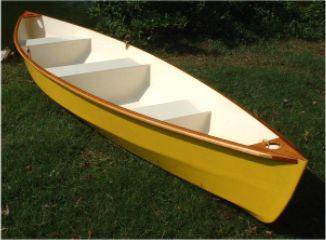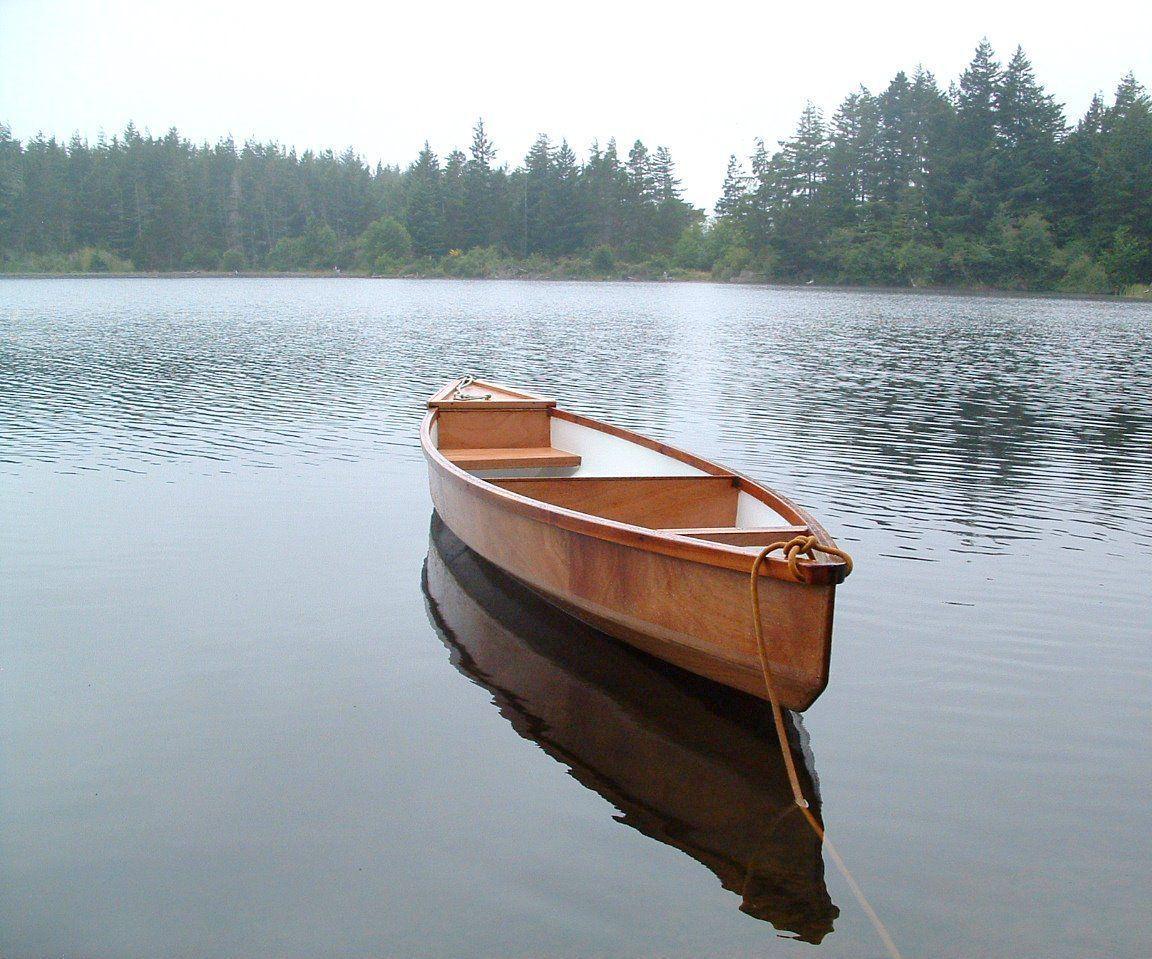The first image is the image on the left, the second image is the image on the right. Analyze the images presented: Is the assertion "At least one boat is partially on land and partially in water." valid? Answer yes or no. No. The first image is the image on the left, the second image is the image on the right. Analyze the images presented: Is the assertion "One image shows a brown canoe floating on water, and the other image shows one canoe sitting on dry ground with no water in sight." valid? Answer yes or no. Yes. 